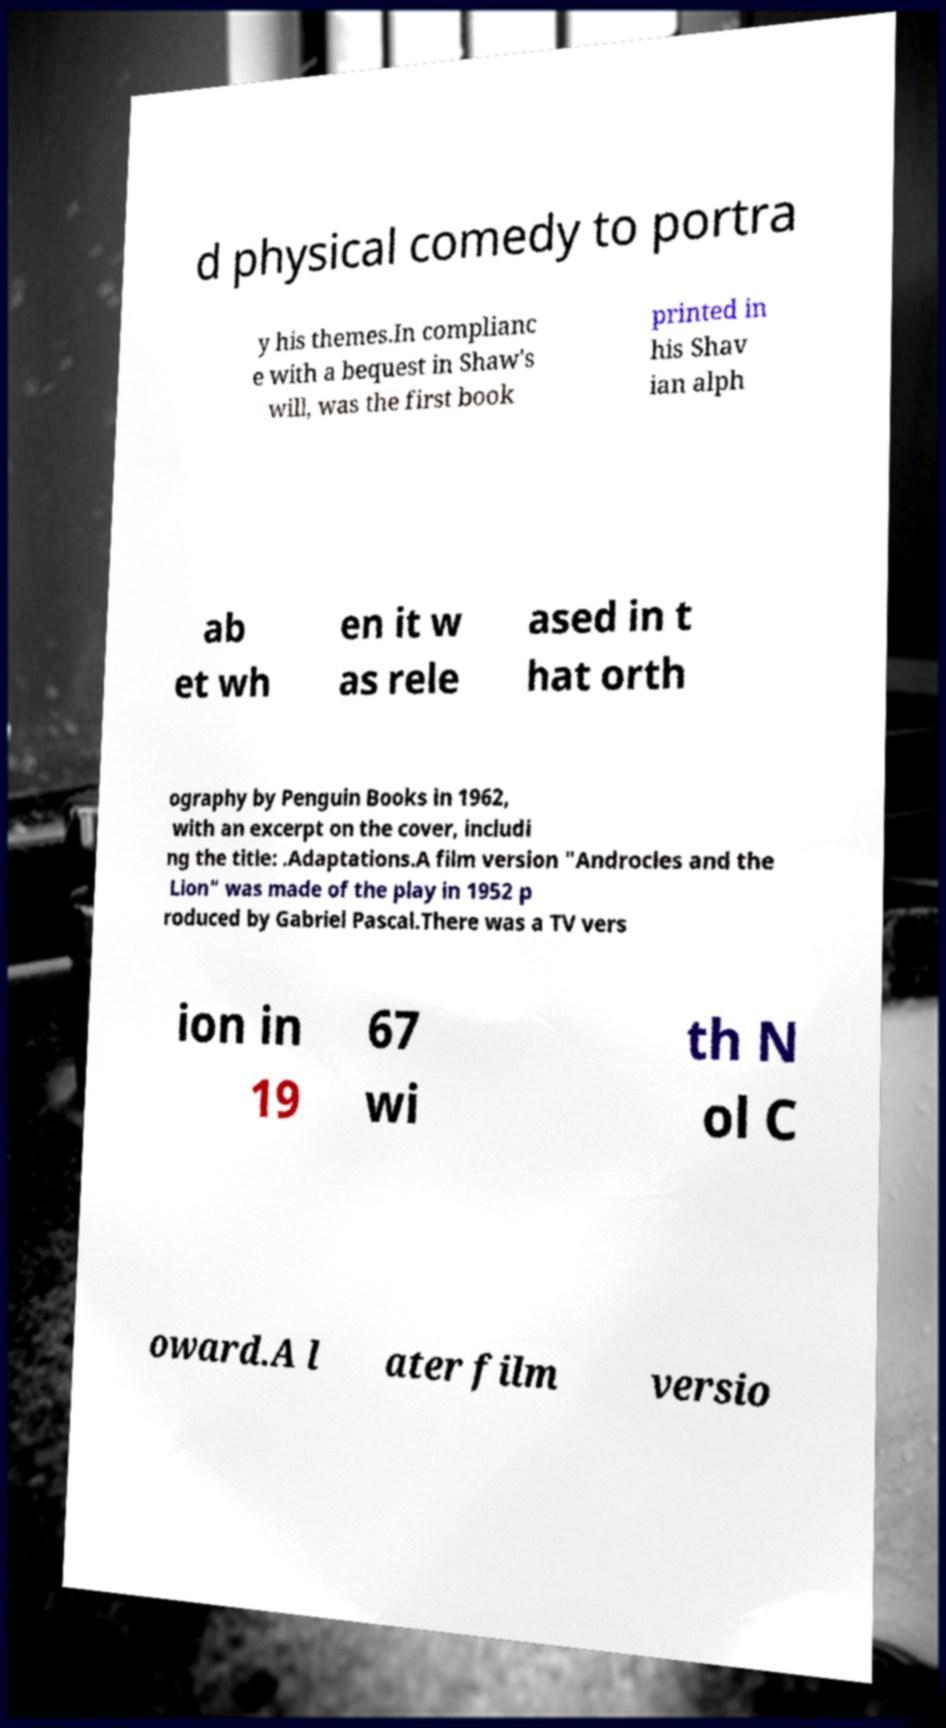Could you extract and type out the text from this image? d physical comedy to portra y his themes.In complianc e with a bequest in Shaw's will, was the first book printed in his Shav ian alph ab et wh en it w as rele ased in t hat orth ography by Penguin Books in 1962, with an excerpt on the cover, includi ng the title: .Adaptations.A film version "Androcles and the Lion" was made of the play in 1952 p roduced by Gabriel Pascal.There was a TV vers ion in 19 67 wi th N ol C oward.A l ater film versio 